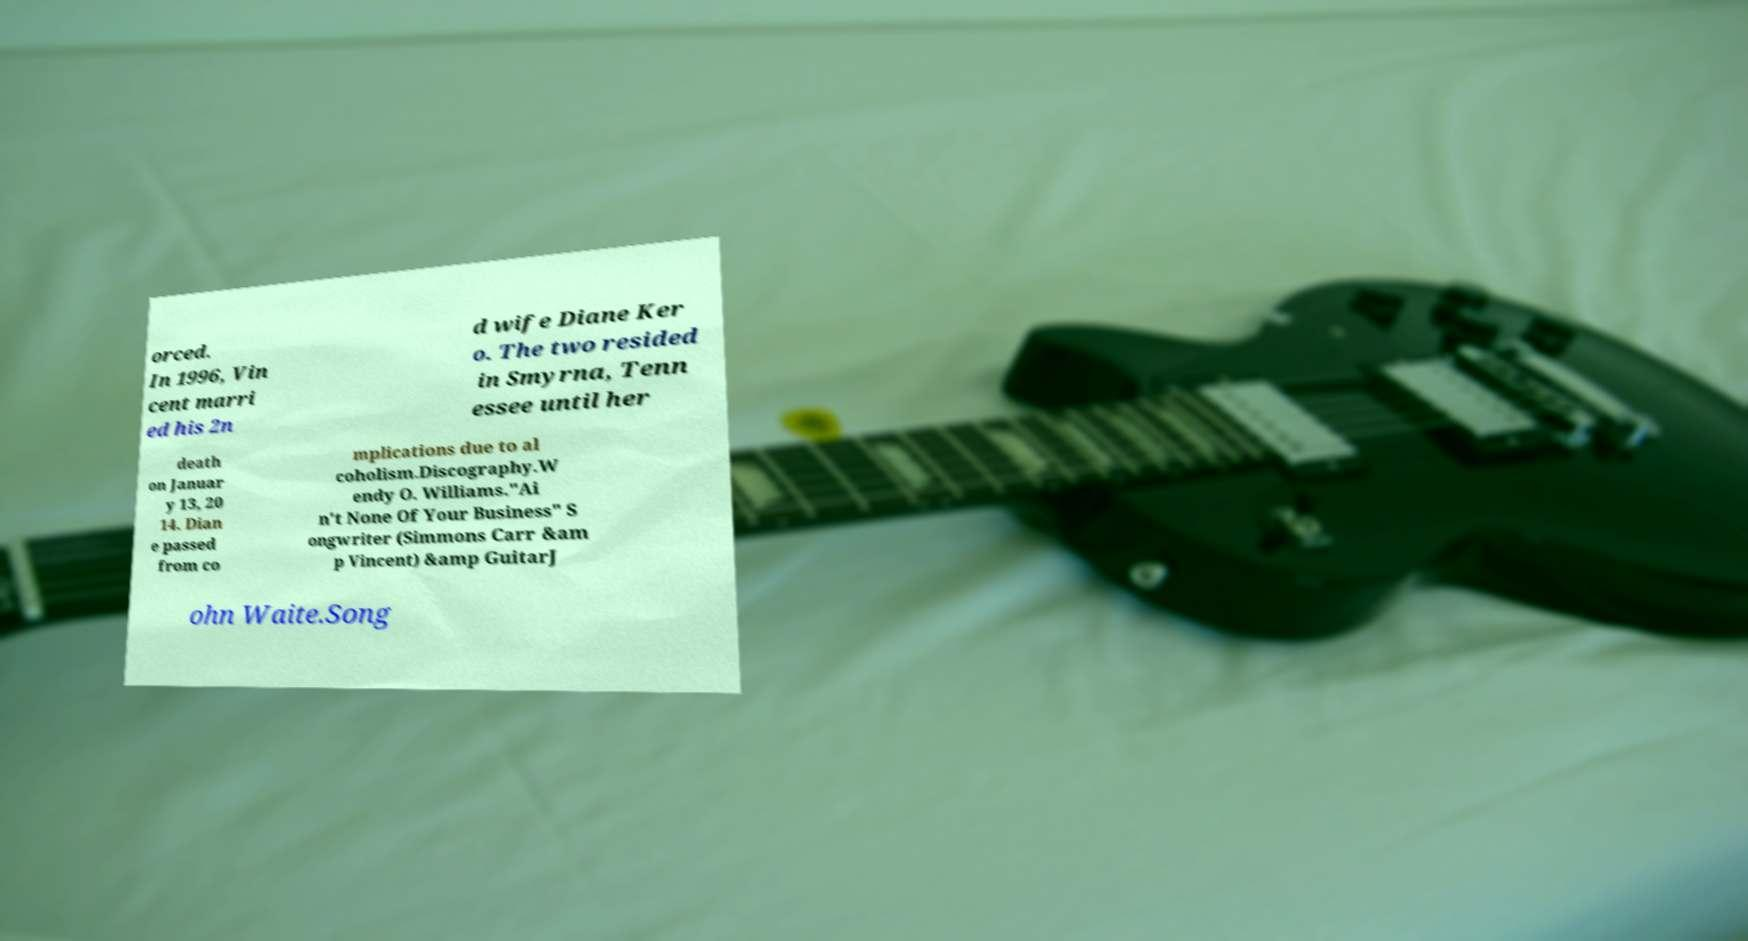Please identify and transcribe the text found in this image. orced. In 1996, Vin cent marri ed his 2n d wife Diane Ker o. The two resided in Smyrna, Tenn essee until her death on Januar y 13, 20 14. Dian e passed from co mplications due to al coholism.Discography.W endy O. Williams."Ai n't None Of Your Business" S ongwriter (Simmons Carr &am p Vincent) &amp GuitarJ ohn Waite.Song 